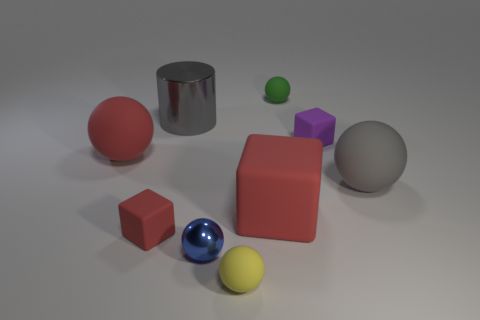Subtract all small blue balls. How many balls are left? 4 Subtract all blue spheres. How many spheres are left? 4 Subtract all cyan spheres. Subtract all purple cylinders. How many spheres are left? 5 Subtract all blocks. How many objects are left? 6 Subtract all small yellow shiny cylinders. Subtract all large matte objects. How many objects are left? 6 Add 4 yellow spheres. How many yellow spheres are left? 5 Add 2 cyan cylinders. How many cyan cylinders exist? 2 Subtract 1 purple cubes. How many objects are left? 8 